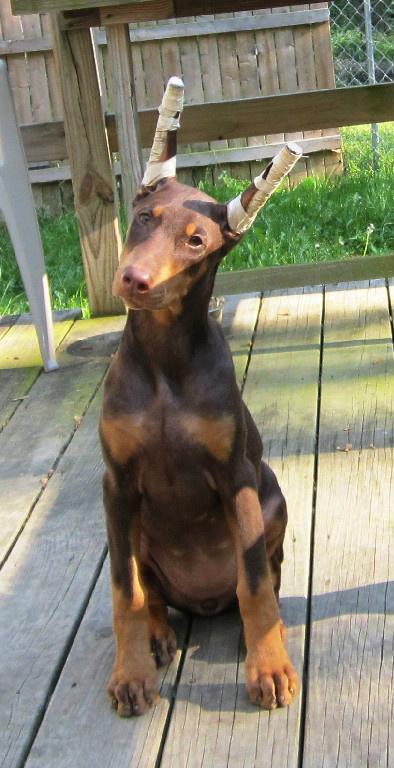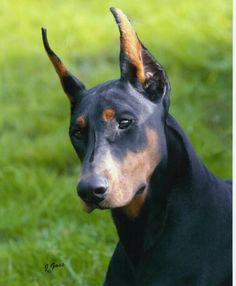The first image is the image on the left, the second image is the image on the right. Considering the images on both sides, is "The left and right image contains the same number of dogs with one facing forward and the other facing sideways." valid? Answer yes or no. No. The first image is the image on the left, the second image is the image on the right. Considering the images on both sides, is "Two dogs are standing." valid? Answer yes or no. No. 